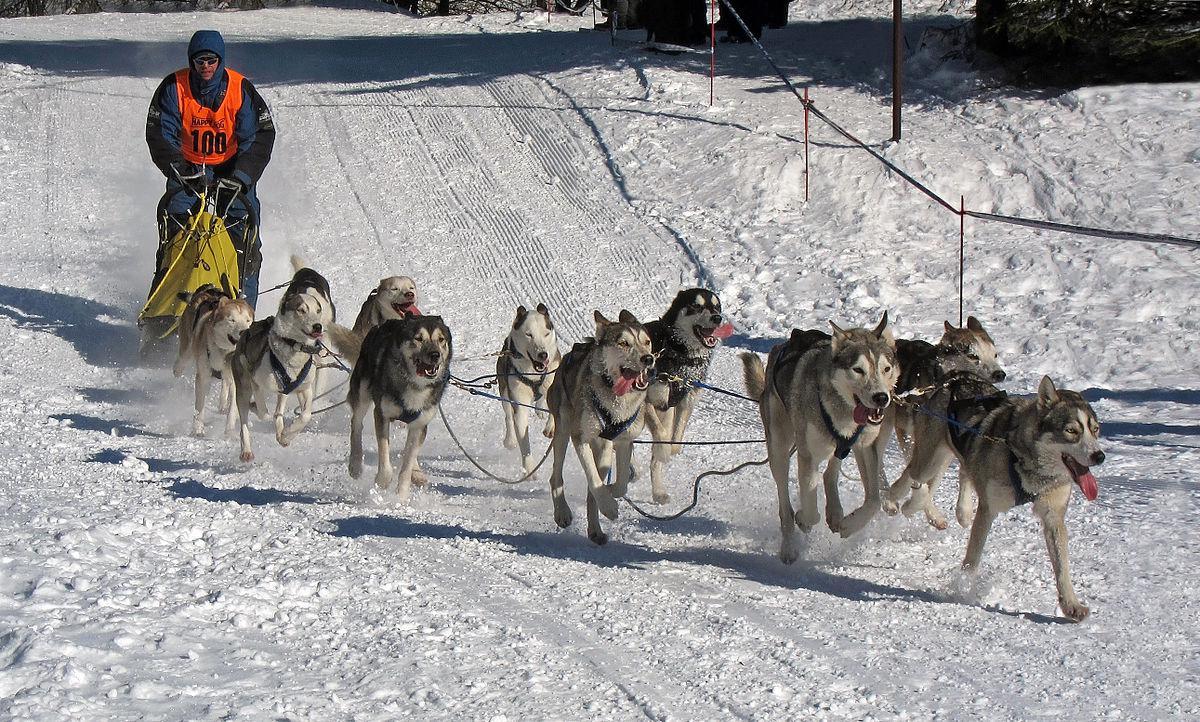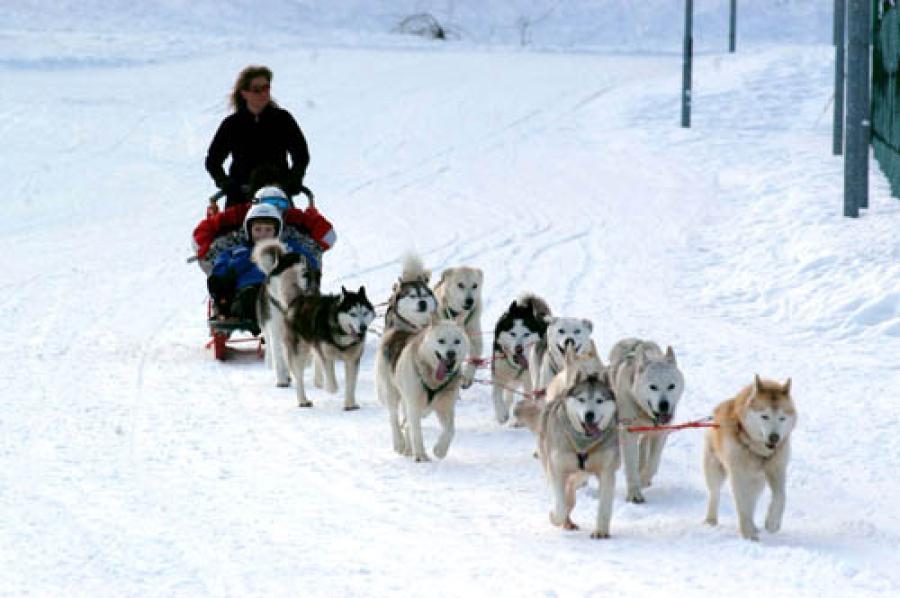The first image is the image on the left, the second image is the image on the right. Assess this claim about the two images: "Right image shows a sled team heading rightward and downward, with no vegetation along the trail.". Correct or not? Answer yes or no. Yes. The first image is the image on the left, the second image is the image on the right. Given the left and right images, does the statement "The lead dog pulling the team is tan." hold true? Answer yes or no. Yes. 